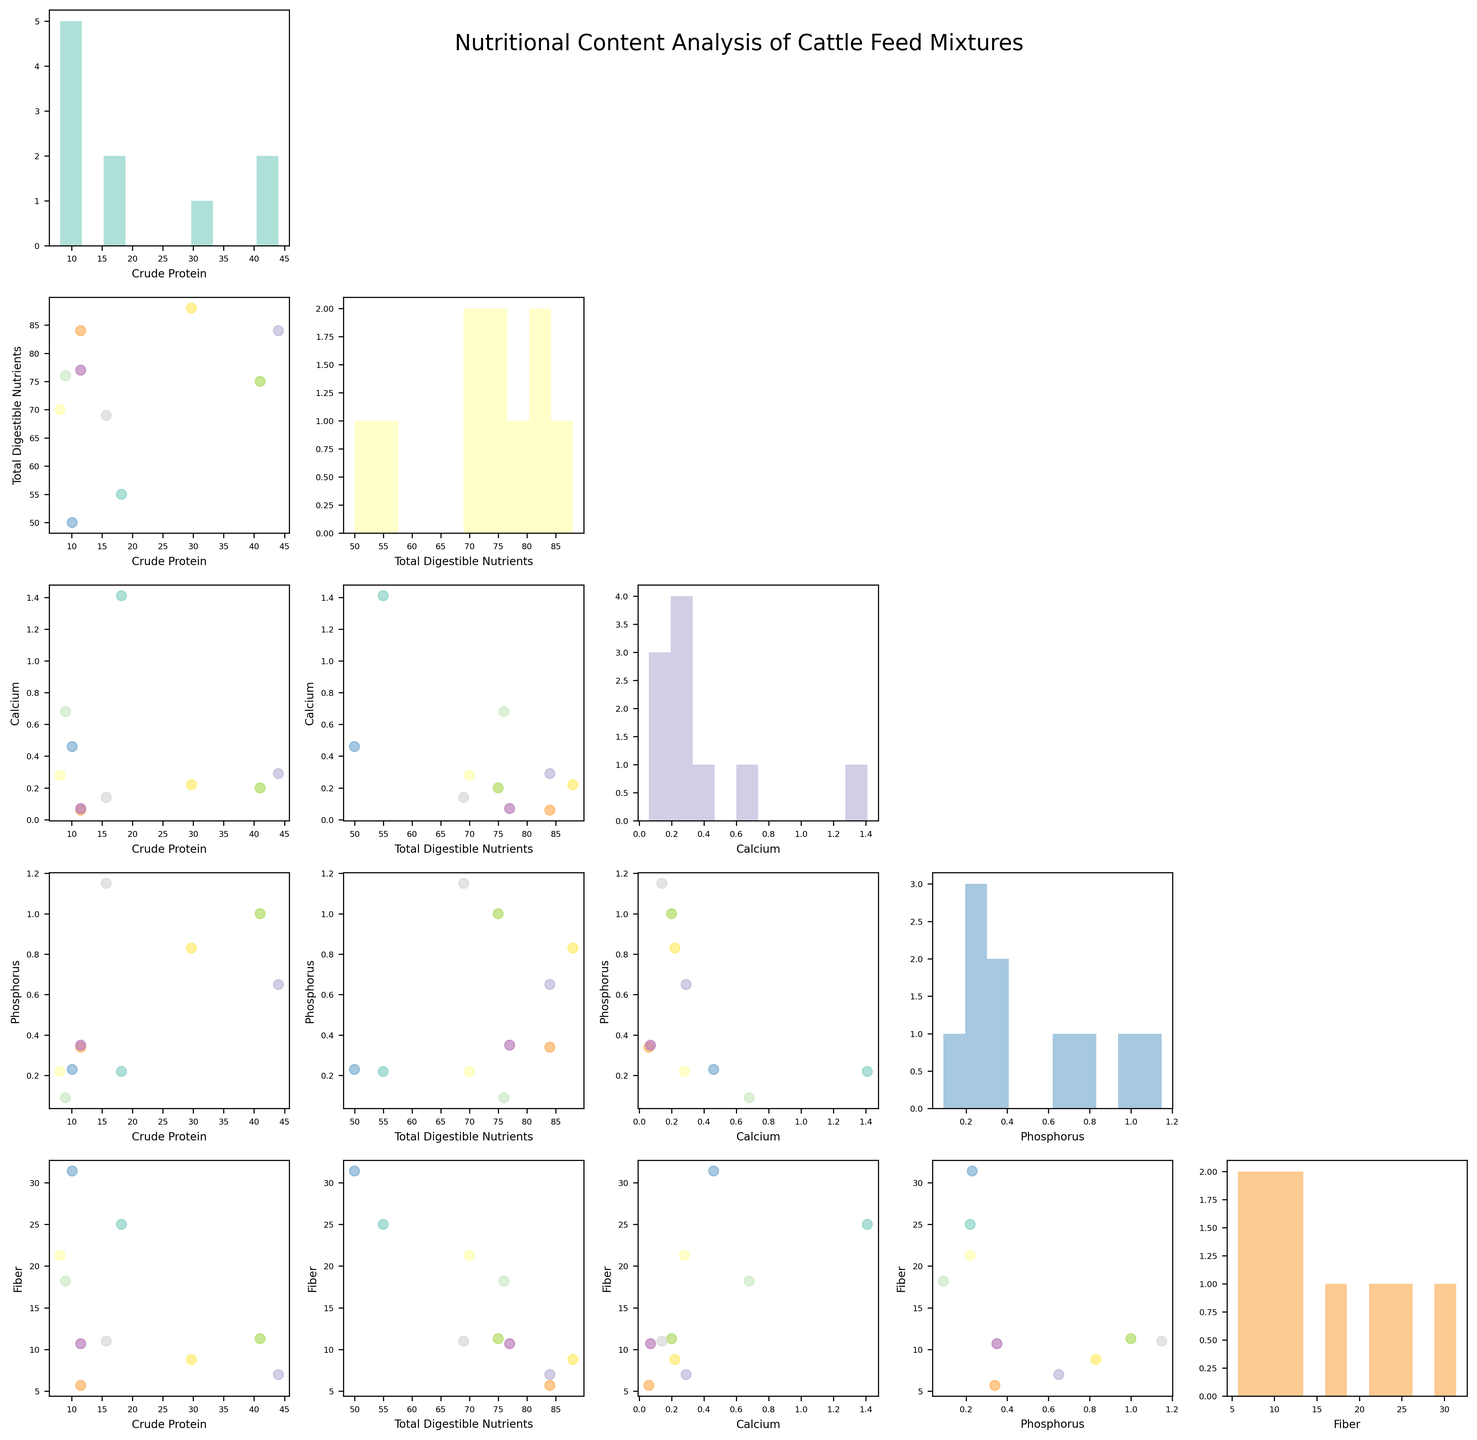Which nutrient has the highest values in the dataset on the scatterplot matrix? Look for the scatter plot with the highest clusters on the vertical axis. "Crude Protein" has the highest values, especially shown by Soybean Meal, which is around 44%.
Answer: Crude Protein How does the distribution of Crude Protein look? Check the histogram on the diagonal displays for Crude Protein. Notice the distribution where Soybean Meal and Cottonseed Meal peak highly.
Answer: Skewed with high peaks Which two nutrients have the strongest correlation based on the scatterplot matrix? Look for the scatter plot sections with the tightest clustering along a diagonal line. "Crude Protein" and "Phosphorus" show a strong correlation in their scatterplot cell.
Answer: Crude Protein and Phosphorus Which feed type stands out with the highest Fiber content? Locate the highest points in the Fiber column. Grass Hay reaches the highest Fiber content, around 31.4%.
Answer: Grass Hay Is there a feed type with both low Crude Protein and high Total Digestible Nutrients? Search for an intersection of low points in Crude Protein and high values in Total Digestible Nutrients. Barley Grain comes to mind with 11.5% Crude Protein and 84% Total Digestible Nutrients.
Answer: Barley Grain What are the general trends between Calcium and Total Digestible Nutrients? Examine the scatter plot of these two nutrients. Notice that there's no strong correlation, as points are widely scattered without a distinct trend.
Answer: No strong correlation Which feed type offers the highest balance in terms of both Crude Protein and Fiber? Identify a feed that lies at moderate to high ranges in both Crude Protein and Fiber scatter plot. Alfalfa Hay offers moderate values at both 18.2% Crude Protein and 25.0% Fiber.
Answer: Alfalfa Hay Is there a clear outlier for any nutrient based on the histograms? Look at the histograms for extreme peaks. Soybean Meal is a clear outlier in Crude Protein with around 44%.
Answer: Soybean Meal in Crude Protein Does the scatterplot matrix show any nutrient that is consistently low for all feed types? Find scatter plots where most feed types are clustered at lower values. Calcium levels appear consistently low when compared across various feed types.
Answer: Calcium 